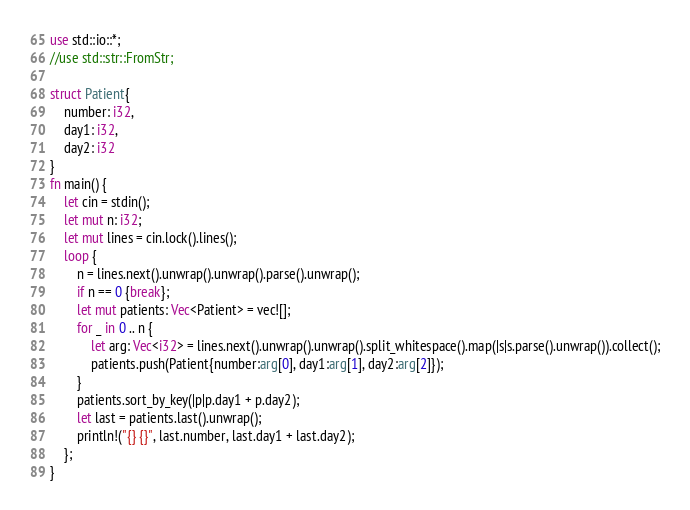<code> <loc_0><loc_0><loc_500><loc_500><_Rust_>use std::io::*;
//use std::str::FromStr;

struct Patient{
    number: i32,
    day1: i32,
    day2: i32
}
fn main() {
    let cin = stdin();
    let mut n: i32;
    let mut lines = cin.lock().lines();
    loop {
        n = lines.next().unwrap().unwrap().parse().unwrap();
        if n == 0 {break};
        let mut patients: Vec<Patient> = vec![];
        for _ in 0 .. n {
            let arg: Vec<i32> = lines.next().unwrap().unwrap().split_whitespace().map(|s|s.parse().unwrap()).collect();
            patients.push(Patient{number:arg[0], day1:arg[1], day2:arg[2]});
        }
        patients.sort_by_key(|p|p.day1 + p.day2);
        let last = patients.last().unwrap();
        println!("{} {}", last.number, last.day1 + last.day2);
    };
}

</code> 